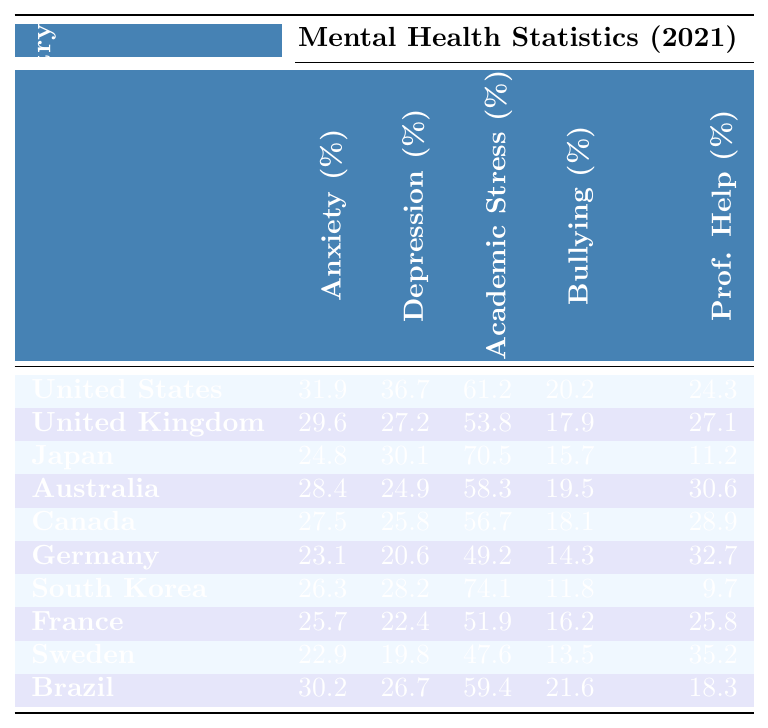What country has the highest anxiety rate among high school students? By looking at the "Anxiety Rate (%)" column, we can see that the United States has the highest anxiety rate at 31.9%.
Answer: United States Which country has the lowest percentage of students seeking professional help? In the "Seeking Professional Help (%)" column, South Korea has the lowest rate at 9.7%.
Answer: South Korea What is the difference in depression rates between the United States and Canada? The depression rate in the United States is 36.7%, and in Canada, it is 25.8%. The difference is 36.7% - 25.8% = 10.9%.
Answer: 10.9% Which two countries have a bullying prevalence higher than 20%? By examining the "Bullying Prevalence (%)" column, we see that the United States (20.2%) and Brazil (21.6%) are the only countries with percentages higher than 20%.
Answer: United States and Brazil Find the average stress from academic pressure among the listed countries. The stress percentages are 61.2, 53.8, 70.5, 58.3, 56.7, 49.2, 74.1, 51.9, 47.6, and 59.4. Adding these values gives a total of  601.8%. There are 10 countries, so the average is 601.8 / 10 = 60.18%.
Answer: 60.18% Is it true that Japan has the highest rate of stress from academic pressure? Checking the "Stress from Academic Pressure (%)" column reveals that Japan (70.5%) has the highest value. Thus, the statement is true.
Answer: True Which country has a higher anxiety rate, Australia or Germany? Australia has an anxiety rate of 28.4% while Germany has an anxiety rate of 23.1%. Since 28.4% is greater than 23.1%, Australia has the higher anxiety rate.
Answer: Australia What is the total percentage of students who reported being bullied in the three countries with the highest rates? The countries with the highest rates of bullying are the United States (20.2%), Brazil (21.6%), and Canada (18.1%). Adding these gives: 20.2 + 21.6 + 18.1 = 59.9%.
Answer: 59.9% How does the anxiety rate in Sweden compare to that in the United Kingdom? Sweden has an anxiety rate of 22.9% while the United Kingdom has 29.6%. Since 22.9% is less than 29.6%, Sweden's rate is lower.
Answer: Sweden's rate is lower What is the relationship between academic stress and seeking professional help among South Korean students? South Korea has a high academic stress rate (74.1%) and a low rate of seeking professional help (9.7%). This suggests that despite high stress, very few students seek help.
Answer: High stress, low help-seeking 